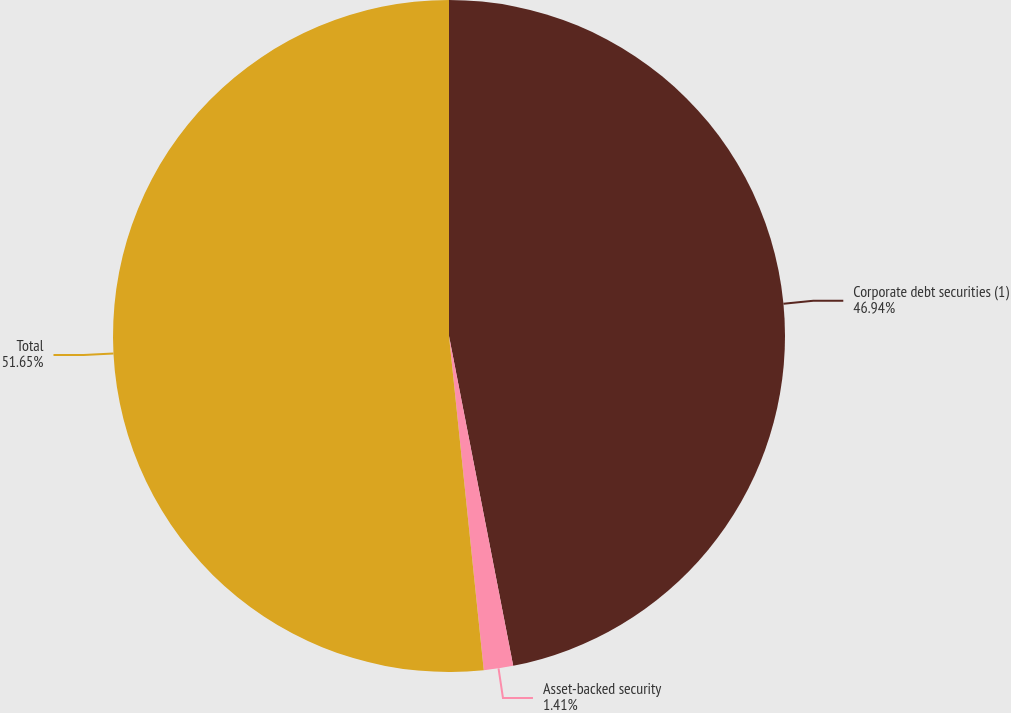Convert chart to OTSL. <chart><loc_0><loc_0><loc_500><loc_500><pie_chart><fcel>Corporate debt securities (1)<fcel>Asset-backed security<fcel>Total<nl><fcel>46.94%<fcel>1.41%<fcel>51.65%<nl></chart> 